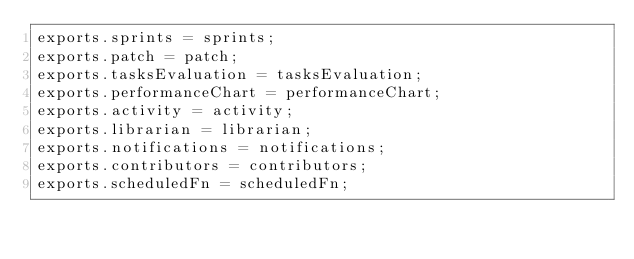Convert code to text. <code><loc_0><loc_0><loc_500><loc_500><_JavaScript_>exports.sprints = sprints;
exports.patch = patch;
exports.tasksEvaluation = tasksEvaluation;
exports.performanceChart = performanceChart;
exports.activity = activity;
exports.librarian = librarian;
exports.notifications = notifications;
exports.contributors = contributors;
exports.scheduledFn = scheduledFn;</code> 